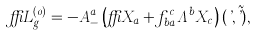Convert formula to latex. <formula><loc_0><loc_0><loc_500><loc_500>\delta L _ { g } ^ { ( 0 ) } = - A _ { - } ^ { a } \left ( \delta X _ { a } + f ^ { c } _ { b a } \Lambda ^ { b } X _ { c } \right ) ( \varphi , \tilde { \varphi } ) ,</formula> 